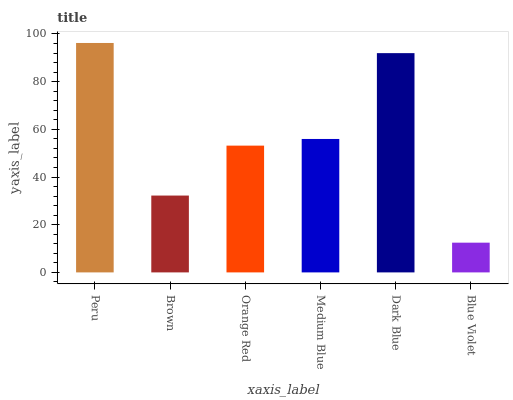Is Blue Violet the minimum?
Answer yes or no. Yes. Is Peru the maximum?
Answer yes or no. Yes. Is Brown the minimum?
Answer yes or no. No. Is Brown the maximum?
Answer yes or no. No. Is Peru greater than Brown?
Answer yes or no. Yes. Is Brown less than Peru?
Answer yes or no. Yes. Is Brown greater than Peru?
Answer yes or no. No. Is Peru less than Brown?
Answer yes or no. No. Is Medium Blue the high median?
Answer yes or no. Yes. Is Orange Red the low median?
Answer yes or no. Yes. Is Blue Violet the high median?
Answer yes or no. No. Is Blue Violet the low median?
Answer yes or no. No. 